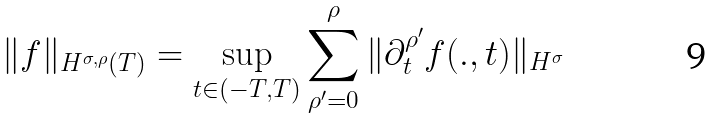Convert formula to latex. <formula><loc_0><loc_0><loc_500><loc_500>\| f \| _ { H ^ { \sigma , \rho } ( T ) } = \sup _ { t \in ( - T , T ) } \sum _ { \rho ^ { \prime } = 0 } ^ { \rho } \| \partial _ { t } ^ { \rho ^ { \prime } } f ( . , t ) \| _ { H ^ { \sigma } }</formula> 